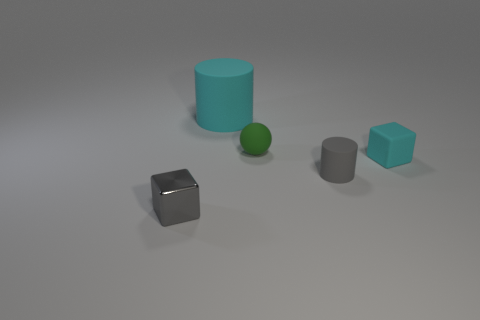There is a cylinder that is the same size as the rubber block; what is its color?
Offer a terse response. Gray. The metallic block has what size?
Your answer should be very brief. Small. Does the tiny block that is left of the cyan cylinder have the same material as the gray cylinder?
Your response must be concise. No. Is the tiny cyan rubber thing the same shape as the large matte thing?
Give a very brief answer. No. What is the shape of the gray object on the left side of the cyan matte thing that is behind the cyan object that is right of the big cyan matte cylinder?
Your answer should be very brief. Cube. Do the tiny gray thing right of the tiny shiny thing and the cyan object left of the small green object have the same shape?
Provide a succinct answer. Yes. Are there any green spheres made of the same material as the large thing?
Provide a succinct answer. Yes. What color is the small block behind the block in front of the cyan rubber object to the right of the big cyan rubber thing?
Provide a short and direct response. Cyan. Does the tiny block that is behind the tiny gray metallic object have the same material as the cyan object that is on the left side of the small gray rubber cylinder?
Your answer should be very brief. Yes. What shape is the tiny gray thing on the left side of the tiny gray matte cylinder?
Your answer should be very brief. Cube. 